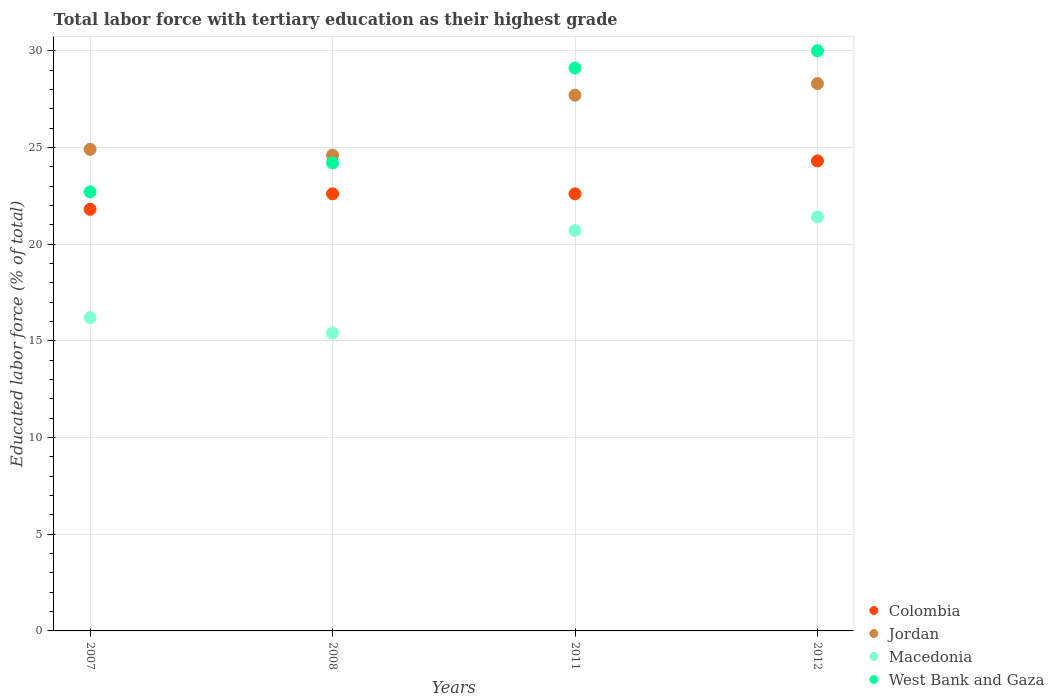How many different coloured dotlines are there?
Make the answer very short. 4. Is the number of dotlines equal to the number of legend labels?
Give a very brief answer. Yes. What is the percentage of male labor force with tertiary education in Jordan in 2011?
Offer a very short reply. 27.7. Across all years, what is the maximum percentage of male labor force with tertiary education in Colombia?
Your response must be concise. 24.3. Across all years, what is the minimum percentage of male labor force with tertiary education in Jordan?
Your answer should be compact. 24.6. What is the total percentage of male labor force with tertiary education in Macedonia in the graph?
Offer a very short reply. 73.7. What is the difference between the percentage of male labor force with tertiary education in Jordan in 2008 and that in 2011?
Your answer should be compact. -3.1. What is the difference between the percentage of male labor force with tertiary education in West Bank and Gaza in 2011 and the percentage of male labor force with tertiary education in Macedonia in 2012?
Your response must be concise. 7.7. What is the average percentage of male labor force with tertiary education in Colombia per year?
Provide a succinct answer. 22.82. In the year 2011, what is the difference between the percentage of male labor force with tertiary education in Macedonia and percentage of male labor force with tertiary education in West Bank and Gaza?
Your answer should be very brief. -8.4. In how many years, is the percentage of male labor force with tertiary education in Macedonia greater than 2 %?
Your answer should be compact. 4. What is the ratio of the percentage of male labor force with tertiary education in Macedonia in 2007 to that in 2011?
Your answer should be compact. 0.78. Is the percentage of male labor force with tertiary education in Macedonia in 2008 less than that in 2011?
Your answer should be very brief. Yes. What is the difference between the highest and the second highest percentage of male labor force with tertiary education in Macedonia?
Give a very brief answer. 0.7. Is it the case that in every year, the sum of the percentage of male labor force with tertiary education in Jordan and percentage of male labor force with tertiary education in West Bank and Gaza  is greater than the sum of percentage of male labor force with tertiary education in Colombia and percentage of male labor force with tertiary education in Macedonia?
Provide a short and direct response. Yes. How many years are there in the graph?
Keep it short and to the point. 4. Are the values on the major ticks of Y-axis written in scientific E-notation?
Offer a very short reply. No. Does the graph contain any zero values?
Provide a short and direct response. No. Does the graph contain grids?
Offer a very short reply. Yes. Where does the legend appear in the graph?
Ensure brevity in your answer.  Bottom right. How many legend labels are there?
Your answer should be very brief. 4. What is the title of the graph?
Provide a succinct answer. Total labor force with tertiary education as their highest grade. Does "Congo (Republic)" appear as one of the legend labels in the graph?
Your response must be concise. No. What is the label or title of the X-axis?
Ensure brevity in your answer.  Years. What is the label or title of the Y-axis?
Provide a succinct answer. Educated labor force (% of total). What is the Educated labor force (% of total) of Colombia in 2007?
Provide a succinct answer. 21.8. What is the Educated labor force (% of total) in Jordan in 2007?
Keep it short and to the point. 24.9. What is the Educated labor force (% of total) in Macedonia in 2007?
Offer a terse response. 16.2. What is the Educated labor force (% of total) of West Bank and Gaza in 2007?
Make the answer very short. 22.7. What is the Educated labor force (% of total) in Colombia in 2008?
Provide a short and direct response. 22.6. What is the Educated labor force (% of total) in Jordan in 2008?
Offer a very short reply. 24.6. What is the Educated labor force (% of total) of Macedonia in 2008?
Your answer should be compact. 15.4. What is the Educated labor force (% of total) of West Bank and Gaza in 2008?
Your response must be concise. 24.2. What is the Educated labor force (% of total) of Colombia in 2011?
Make the answer very short. 22.6. What is the Educated labor force (% of total) in Jordan in 2011?
Your response must be concise. 27.7. What is the Educated labor force (% of total) of Macedonia in 2011?
Give a very brief answer. 20.7. What is the Educated labor force (% of total) of West Bank and Gaza in 2011?
Offer a terse response. 29.1. What is the Educated labor force (% of total) in Colombia in 2012?
Give a very brief answer. 24.3. What is the Educated labor force (% of total) of Jordan in 2012?
Your response must be concise. 28.3. What is the Educated labor force (% of total) of Macedonia in 2012?
Keep it short and to the point. 21.4. What is the Educated labor force (% of total) in West Bank and Gaza in 2012?
Your response must be concise. 30. Across all years, what is the maximum Educated labor force (% of total) in Colombia?
Keep it short and to the point. 24.3. Across all years, what is the maximum Educated labor force (% of total) in Jordan?
Your answer should be very brief. 28.3. Across all years, what is the maximum Educated labor force (% of total) of Macedonia?
Your answer should be very brief. 21.4. Across all years, what is the minimum Educated labor force (% of total) in Colombia?
Provide a short and direct response. 21.8. Across all years, what is the minimum Educated labor force (% of total) in Jordan?
Ensure brevity in your answer.  24.6. Across all years, what is the minimum Educated labor force (% of total) in Macedonia?
Keep it short and to the point. 15.4. Across all years, what is the minimum Educated labor force (% of total) of West Bank and Gaza?
Offer a very short reply. 22.7. What is the total Educated labor force (% of total) in Colombia in the graph?
Your response must be concise. 91.3. What is the total Educated labor force (% of total) in Jordan in the graph?
Offer a very short reply. 105.5. What is the total Educated labor force (% of total) in Macedonia in the graph?
Give a very brief answer. 73.7. What is the total Educated labor force (% of total) in West Bank and Gaza in the graph?
Ensure brevity in your answer.  106. What is the difference between the Educated labor force (% of total) of Jordan in 2007 and that in 2008?
Your answer should be very brief. 0.3. What is the difference between the Educated labor force (% of total) in West Bank and Gaza in 2007 and that in 2008?
Your answer should be very brief. -1.5. What is the difference between the Educated labor force (% of total) of Colombia in 2007 and that in 2011?
Your answer should be compact. -0.8. What is the difference between the Educated labor force (% of total) in Jordan in 2007 and that in 2011?
Ensure brevity in your answer.  -2.8. What is the difference between the Educated labor force (% of total) in West Bank and Gaza in 2007 and that in 2011?
Your answer should be compact. -6.4. What is the difference between the Educated labor force (% of total) in Macedonia in 2007 and that in 2012?
Offer a very short reply. -5.2. What is the difference between the Educated labor force (% of total) in West Bank and Gaza in 2007 and that in 2012?
Offer a very short reply. -7.3. What is the difference between the Educated labor force (% of total) of Colombia in 2008 and that in 2011?
Provide a succinct answer. 0. What is the difference between the Educated labor force (% of total) of Jordan in 2008 and that in 2011?
Keep it short and to the point. -3.1. What is the difference between the Educated labor force (% of total) in Macedonia in 2008 and that in 2011?
Your response must be concise. -5.3. What is the difference between the Educated labor force (% of total) of West Bank and Gaza in 2008 and that in 2011?
Your answer should be compact. -4.9. What is the difference between the Educated labor force (% of total) in Colombia in 2008 and that in 2012?
Your answer should be compact. -1.7. What is the difference between the Educated labor force (% of total) of Jordan in 2008 and that in 2012?
Provide a short and direct response. -3.7. What is the difference between the Educated labor force (% of total) in Colombia in 2011 and that in 2012?
Your response must be concise. -1.7. What is the difference between the Educated labor force (% of total) in Macedonia in 2011 and that in 2012?
Your answer should be very brief. -0.7. What is the difference between the Educated labor force (% of total) of West Bank and Gaza in 2011 and that in 2012?
Ensure brevity in your answer.  -0.9. What is the difference between the Educated labor force (% of total) of Colombia in 2007 and the Educated labor force (% of total) of Jordan in 2008?
Make the answer very short. -2.8. What is the difference between the Educated labor force (% of total) in Colombia in 2007 and the Educated labor force (% of total) in Macedonia in 2008?
Keep it short and to the point. 6.4. What is the difference between the Educated labor force (% of total) in Colombia in 2007 and the Educated labor force (% of total) in West Bank and Gaza in 2008?
Your answer should be very brief. -2.4. What is the difference between the Educated labor force (% of total) in Jordan in 2007 and the Educated labor force (% of total) in West Bank and Gaza in 2008?
Your answer should be very brief. 0.7. What is the difference between the Educated labor force (% of total) in Colombia in 2007 and the Educated labor force (% of total) in West Bank and Gaza in 2011?
Provide a succinct answer. -7.3. What is the difference between the Educated labor force (% of total) in Jordan in 2007 and the Educated labor force (% of total) in Macedonia in 2011?
Ensure brevity in your answer.  4.2. What is the difference between the Educated labor force (% of total) of Macedonia in 2007 and the Educated labor force (% of total) of West Bank and Gaza in 2011?
Your answer should be very brief. -12.9. What is the difference between the Educated labor force (% of total) of Colombia in 2007 and the Educated labor force (% of total) of Jordan in 2012?
Make the answer very short. -6.5. What is the difference between the Educated labor force (% of total) in Colombia in 2007 and the Educated labor force (% of total) in West Bank and Gaza in 2012?
Your answer should be very brief. -8.2. What is the difference between the Educated labor force (% of total) of Jordan in 2007 and the Educated labor force (% of total) of Macedonia in 2012?
Make the answer very short. 3.5. What is the difference between the Educated labor force (% of total) of Macedonia in 2007 and the Educated labor force (% of total) of West Bank and Gaza in 2012?
Give a very brief answer. -13.8. What is the difference between the Educated labor force (% of total) of Colombia in 2008 and the Educated labor force (% of total) of Jordan in 2011?
Make the answer very short. -5.1. What is the difference between the Educated labor force (% of total) of Colombia in 2008 and the Educated labor force (% of total) of West Bank and Gaza in 2011?
Provide a short and direct response. -6.5. What is the difference between the Educated labor force (% of total) in Macedonia in 2008 and the Educated labor force (% of total) in West Bank and Gaza in 2011?
Your response must be concise. -13.7. What is the difference between the Educated labor force (% of total) in Colombia in 2008 and the Educated labor force (% of total) in Macedonia in 2012?
Your answer should be compact. 1.2. What is the difference between the Educated labor force (% of total) in Jordan in 2008 and the Educated labor force (% of total) in West Bank and Gaza in 2012?
Make the answer very short. -5.4. What is the difference between the Educated labor force (% of total) of Macedonia in 2008 and the Educated labor force (% of total) of West Bank and Gaza in 2012?
Your response must be concise. -14.6. What is the difference between the Educated labor force (% of total) of Colombia in 2011 and the Educated labor force (% of total) of Jordan in 2012?
Your answer should be compact. -5.7. What is the difference between the Educated labor force (% of total) in Colombia in 2011 and the Educated labor force (% of total) in Macedonia in 2012?
Make the answer very short. 1.2. What is the difference between the Educated labor force (% of total) in Jordan in 2011 and the Educated labor force (% of total) in Macedonia in 2012?
Your answer should be very brief. 6.3. What is the difference between the Educated labor force (% of total) in Macedonia in 2011 and the Educated labor force (% of total) in West Bank and Gaza in 2012?
Ensure brevity in your answer.  -9.3. What is the average Educated labor force (% of total) of Colombia per year?
Your response must be concise. 22.82. What is the average Educated labor force (% of total) of Jordan per year?
Your answer should be compact. 26.38. What is the average Educated labor force (% of total) in Macedonia per year?
Provide a succinct answer. 18.43. What is the average Educated labor force (% of total) of West Bank and Gaza per year?
Offer a terse response. 26.5. In the year 2007, what is the difference between the Educated labor force (% of total) in Colombia and Educated labor force (% of total) in Jordan?
Give a very brief answer. -3.1. In the year 2007, what is the difference between the Educated labor force (% of total) of Colombia and Educated labor force (% of total) of Macedonia?
Offer a very short reply. 5.6. In the year 2007, what is the difference between the Educated labor force (% of total) of Jordan and Educated labor force (% of total) of Macedonia?
Provide a succinct answer. 8.7. In the year 2007, what is the difference between the Educated labor force (% of total) in Jordan and Educated labor force (% of total) in West Bank and Gaza?
Make the answer very short. 2.2. In the year 2007, what is the difference between the Educated labor force (% of total) of Macedonia and Educated labor force (% of total) of West Bank and Gaza?
Keep it short and to the point. -6.5. In the year 2008, what is the difference between the Educated labor force (% of total) in Colombia and Educated labor force (% of total) in Jordan?
Offer a terse response. -2. In the year 2008, what is the difference between the Educated labor force (% of total) in Colombia and Educated labor force (% of total) in Macedonia?
Keep it short and to the point. 7.2. In the year 2008, what is the difference between the Educated labor force (% of total) in Colombia and Educated labor force (% of total) in West Bank and Gaza?
Ensure brevity in your answer.  -1.6. In the year 2008, what is the difference between the Educated labor force (% of total) in Jordan and Educated labor force (% of total) in Macedonia?
Your response must be concise. 9.2. In the year 2008, what is the difference between the Educated labor force (% of total) in Jordan and Educated labor force (% of total) in West Bank and Gaza?
Make the answer very short. 0.4. In the year 2011, what is the difference between the Educated labor force (% of total) of Colombia and Educated labor force (% of total) of Jordan?
Offer a terse response. -5.1. In the year 2011, what is the difference between the Educated labor force (% of total) in Colombia and Educated labor force (% of total) in Macedonia?
Ensure brevity in your answer.  1.9. In the year 2011, what is the difference between the Educated labor force (% of total) of Macedonia and Educated labor force (% of total) of West Bank and Gaza?
Ensure brevity in your answer.  -8.4. In the year 2012, what is the difference between the Educated labor force (% of total) in Jordan and Educated labor force (% of total) in Macedonia?
Offer a terse response. 6.9. In the year 2012, what is the difference between the Educated labor force (% of total) of Macedonia and Educated labor force (% of total) of West Bank and Gaza?
Give a very brief answer. -8.6. What is the ratio of the Educated labor force (% of total) in Colombia in 2007 to that in 2008?
Provide a short and direct response. 0.96. What is the ratio of the Educated labor force (% of total) in Jordan in 2007 to that in 2008?
Your answer should be compact. 1.01. What is the ratio of the Educated labor force (% of total) of Macedonia in 2007 to that in 2008?
Offer a terse response. 1.05. What is the ratio of the Educated labor force (% of total) in West Bank and Gaza in 2007 to that in 2008?
Make the answer very short. 0.94. What is the ratio of the Educated labor force (% of total) in Colombia in 2007 to that in 2011?
Keep it short and to the point. 0.96. What is the ratio of the Educated labor force (% of total) in Jordan in 2007 to that in 2011?
Offer a very short reply. 0.9. What is the ratio of the Educated labor force (% of total) of Macedonia in 2007 to that in 2011?
Provide a short and direct response. 0.78. What is the ratio of the Educated labor force (% of total) of West Bank and Gaza in 2007 to that in 2011?
Your response must be concise. 0.78. What is the ratio of the Educated labor force (% of total) of Colombia in 2007 to that in 2012?
Offer a very short reply. 0.9. What is the ratio of the Educated labor force (% of total) of Jordan in 2007 to that in 2012?
Give a very brief answer. 0.88. What is the ratio of the Educated labor force (% of total) in Macedonia in 2007 to that in 2012?
Your answer should be very brief. 0.76. What is the ratio of the Educated labor force (% of total) of West Bank and Gaza in 2007 to that in 2012?
Keep it short and to the point. 0.76. What is the ratio of the Educated labor force (% of total) of Colombia in 2008 to that in 2011?
Offer a very short reply. 1. What is the ratio of the Educated labor force (% of total) in Jordan in 2008 to that in 2011?
Give a very brief answer. 0.89. What is the ratio of the Educated labor force (% of total) in Macedonia in 2008 to that in 2011?
Make the answer very short. 0.74. What is the ratio of the Educated labor force (% of total) in West Bank and Gaza in 2008 to that in 2011?
Your response must be concise. 0.83. What is the ratio of the Educated labor force (% of total) in Colombia in 2008 to that in 2012?
Ensure brevity in your answer.  0.93. What is the ratio of the Educated labor force (% of total) in Jordan in 2008 to that in 2012?
Offer a very short reply. 0.87. What is the ratio of the Educated labor force (% of total) of Macedonia in 2008 to that in 2012?
Offer a very short reply. 0.72. What is the ratio of the Educated labor force (% of total) of West Bank and Gaza in 2008 to that in 2012?
Ensure brevity in your answer.  0.81. What is the ratio of the Educated labor force (% of total) of Colombia in 2011 to that in 2012?
Make the answer very short. 0.93. What is the ratio of the Educated labor force (% of total) of Jordan in 2011 to that in 2012?
Offer a terse response. 0.98. What is the ratio of the Educated labor force (% of total) in Macedonia in 2011 to that in 2012?
Offer a terse response. 0.97. What is the ratio of the Educated labor force (% of total) of West Bank and Gaza in 2011 to that in 2012?
Provide a succinct answer. 0.97. What is the difference between the highest and the second highest Educated labor force (% of total) in Colombia?
Your answer should be very brief. 1.7. What is the difference between the highest and the second highest Educated labor force (% of total) in Jordan?
Offer a terse response. 0.6. What is the difference between the highest and the second highest Educated labor force (% of total) in Macedonia?
Your answer should be very brief. 0.7. What is the difference between the highest and the lowest Educated labor force (% of total) in Jordan?
Provide a succinct answer. 3.7. What is the difference between the highest and the lowest Educated labor force (% of total) in Macedonia?
Keep it short and to the point. 6. What is the difference between the highest and the lowest Educated labor force (% of total) in West Bank and Gaza?
Provide a succinct answer. 7.3. 